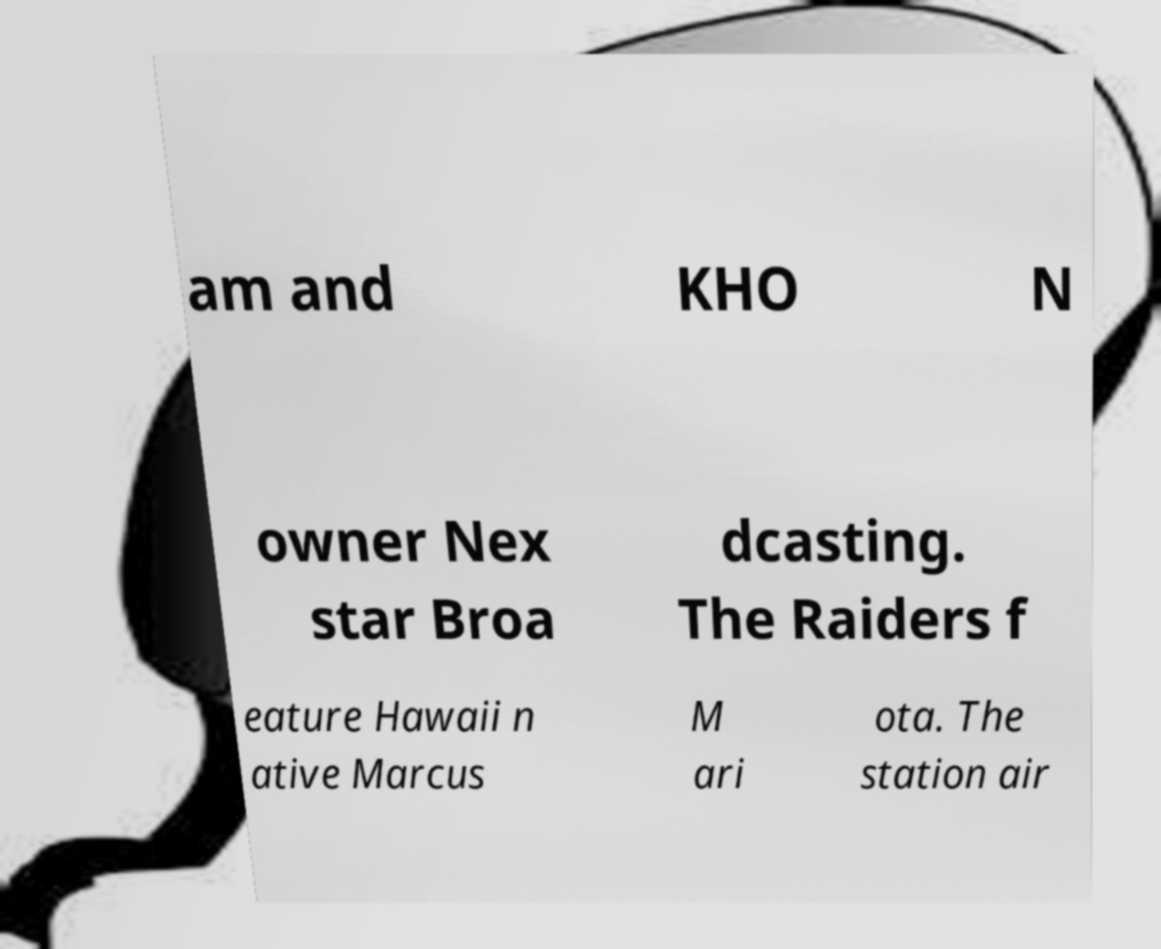Please identify and transcribe the text found in this image. am and KHO N owner Nex star Broa dcasting. The Raiders f eature Hawaii n ative Marcus M ari ota. The station air 